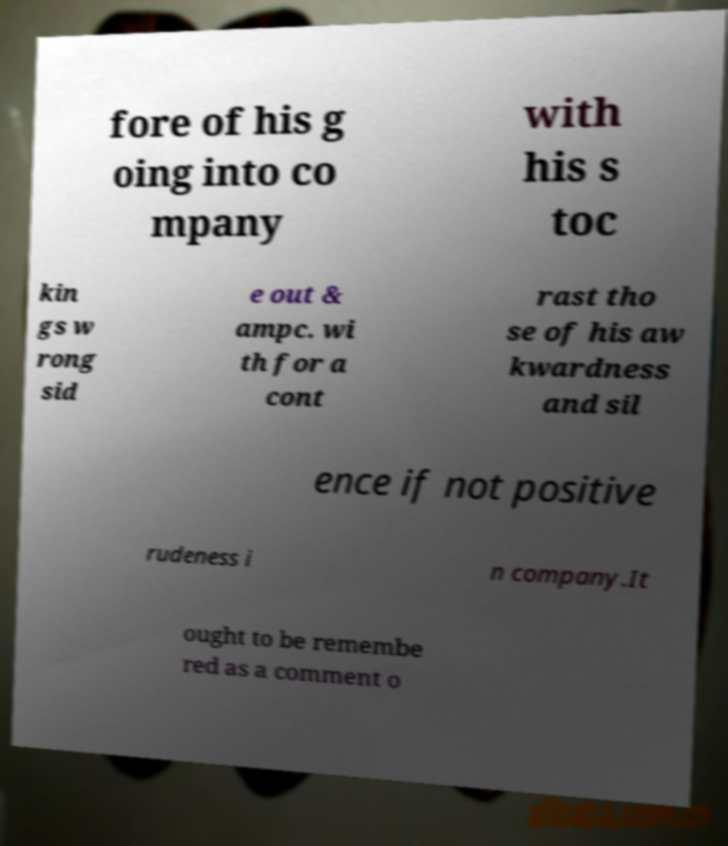Please identify and transcribe the text found in this image. fore of his g oing into co mpany with his s toc kin gs w rong sid e out & ampc. wi th for a cont rast tho se of his aw kwardness and sil ence if not positive rudeness i n company.It ought to be remembe red as a comment o 